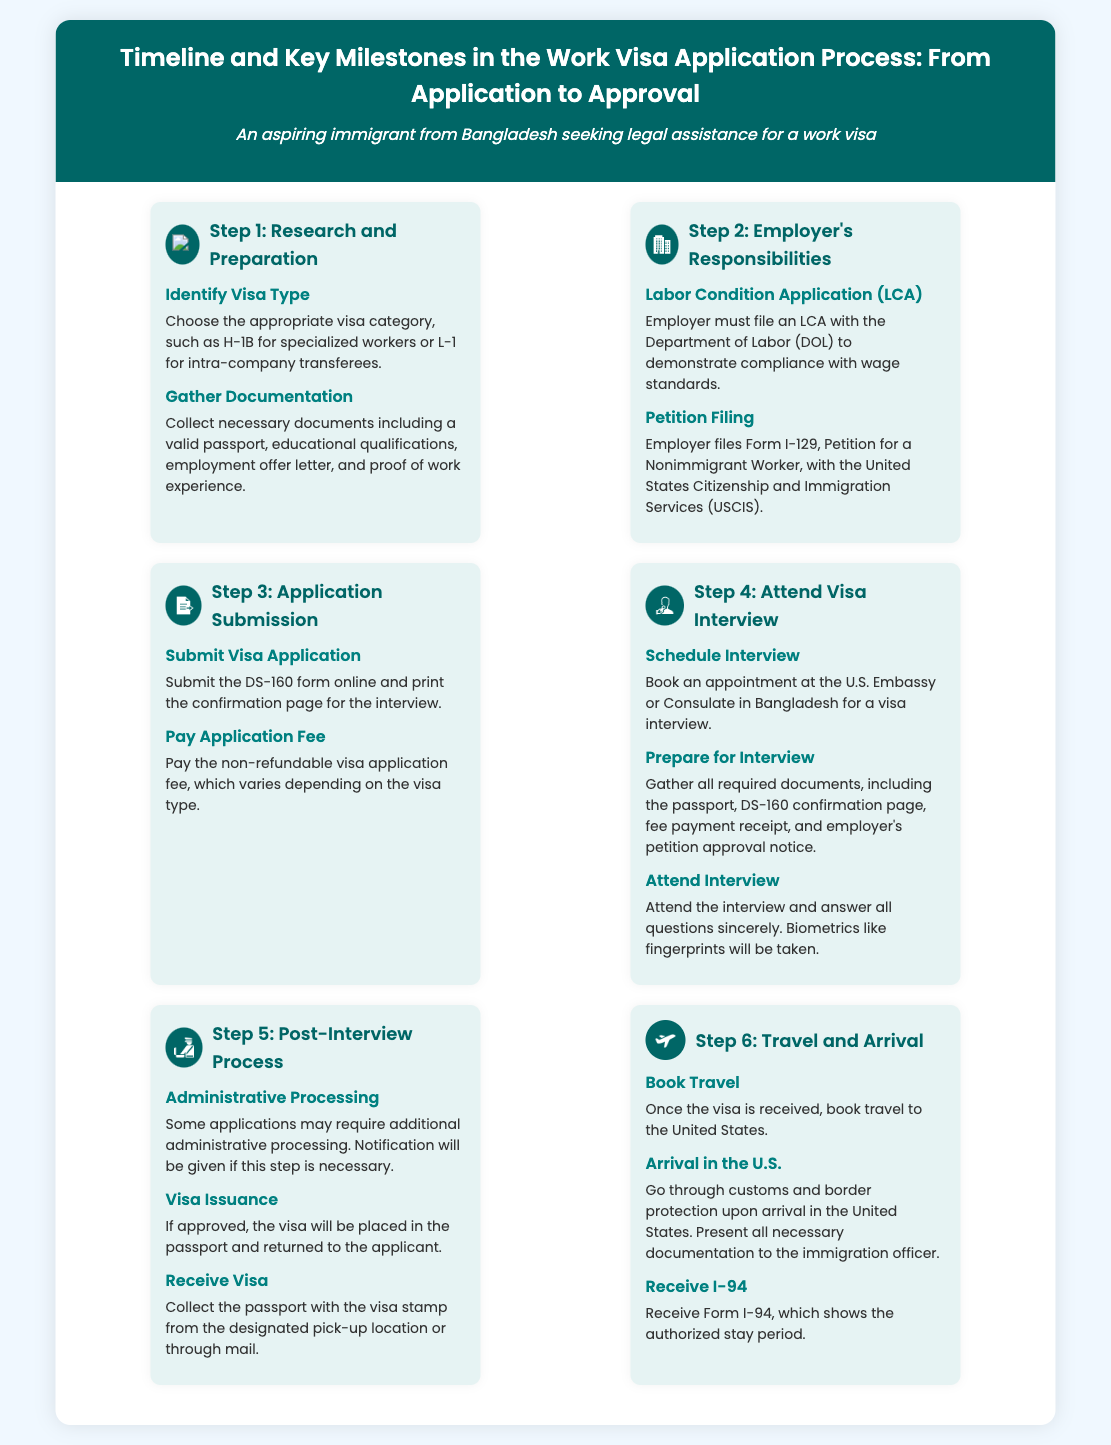what is the first step in the work visa application process? The first step is outlined in the infographics, which describes the initial stage of the process.
Answer: Research and Preparation how many steps are there in the work visa application process? The infographic clearly shows the total number of steps involved in the process.
Answer: 6 what document must the employer file with the Department of Labor? This information is explicitly mentioned in the relevant step for the employer's responsibilities.
Answer: Labor Condition Application (LCA) what is the purpose of the DS-160 form? The purpose of the DS-160 is specified in the section on application submission.
Answer: Submit visa application what happens after the visa interview if the application is approved? The infographic describes the outcome following a successful visa interview.
Answer: Visa Issuance what is received upon arrival in the United States? The final step includes information about what travelers receive upon reaching the U.S.
Answer: Form I-94 what is required from the applicant for the visa interview? The infographic lists necessary documents to prepare for the visa interview.
Answer: Passport, DS-160 confirmation page, fee payment receipt, employer's petition approval notice which step involves booking an appointment at the U.S. Embassy? This activity is outlined in the step dedicated to the visa interview process.
Answer: Attend Visa Interview 